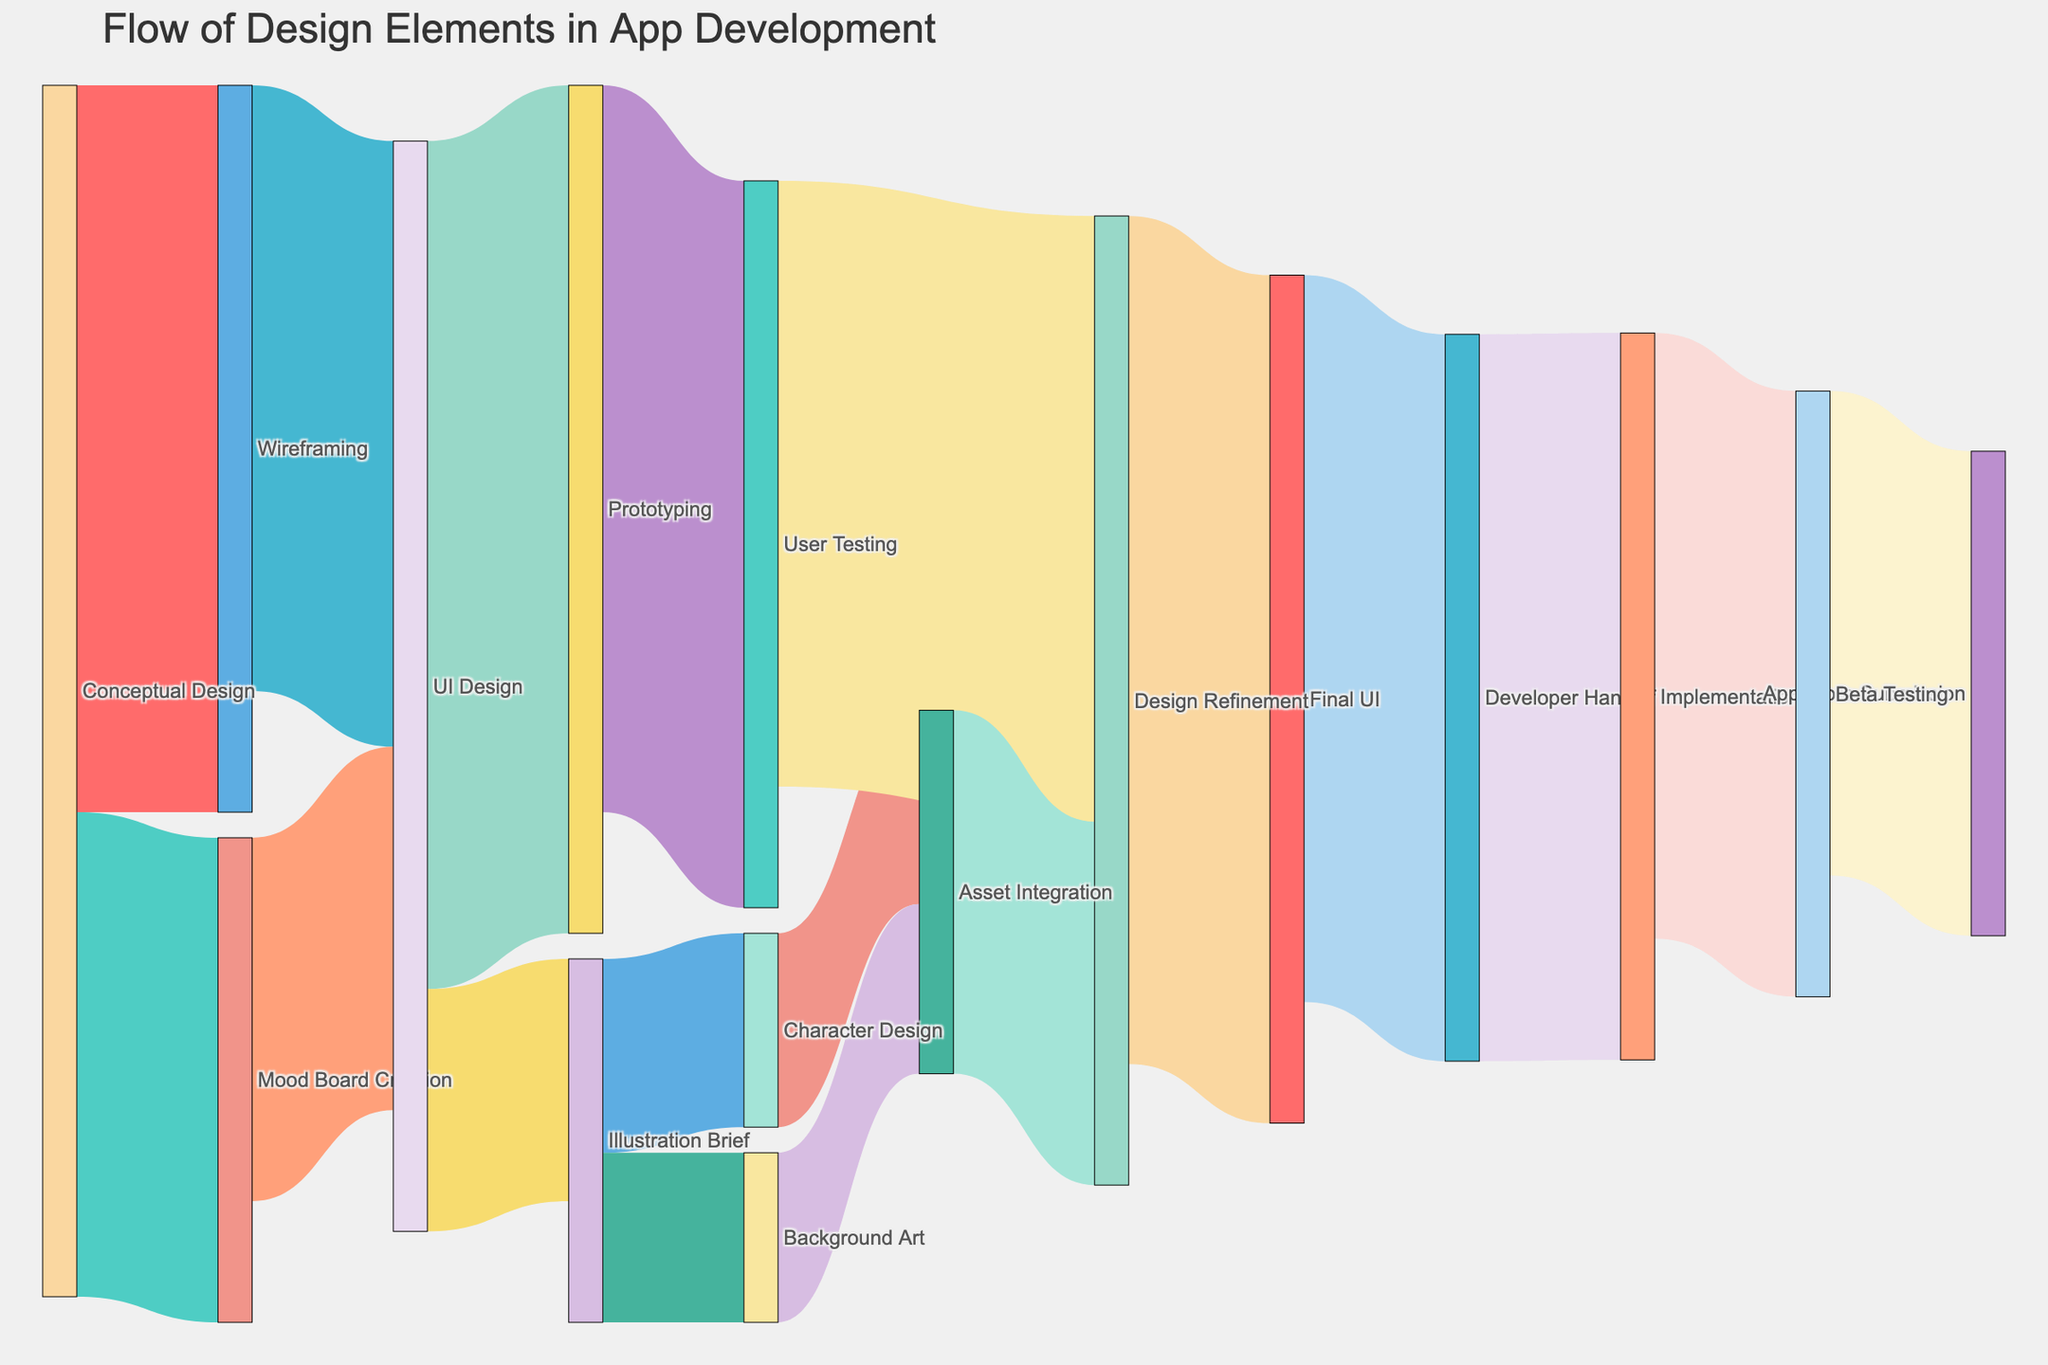What is the title of the Sankey Diagram? The title of a diagram is usually located at the top of the illustration and provides an overview of the content. Here, the title "Flow of Design Elements in App Development" is clearly mentioned at the top of the diagram.
Answer: Flow of Design Elements in App Development What is the total value of flows originating from 'Conceptual Design'? To determine the total value of flows originating from 'Conceptual Design', add the values of all direct outputs: Wireframing (30) and Mood Board Creation (20). Therefore, the total value is 30+20=50.
Answer: 50 Which stage has the highest incoming flow from 'UI Design'? The diagram shows two flows originating from 'UI Design': one going to 'Prototyping' with a value of 35, and the other to 'Illustration Brief' with a value of 10. The highest incoming flow is to 'Prototyping'.
Answer: Prototyping How many design elements flow from 'Illustration Brief' to 'Asset Integration'? To determine the number of design elements flowing to 'Asset Integration', we look at the connections from 'Illustration Brief'. 'Character Design' and 'Background Art' flow to 'Asset Integration' with values of 8 and 7 respectively. Adding these gives 8+7=15.
Answer: 15 Is there any stage where the outgoing value equals the incoming value and what is it? We need to find a stage where the sum of incoming values equals the sum of outgoing values. For example, 'Design Refinement' has incoming values of 25 (from 'User Testing') and 15 (from 'Asset Integration'), totaling 40. Its outgoing value to 'Final UI' is also 40. Thus, outgoing equals incoming for 'Design Refinement'.
Answer: Design Refinement What is the sum of values that eventually lead to 'Implementation'? First, identify the direct flow into 'Implementation': Developer Handoff (30). Now, check what contributes to 'Developer Handoff': Final UI (30). 'Final UI' gets 35 from 'Design Refinement', which in turn gets values from 'User Testing' (25) and 'Asset Integration' (15). Sum the values: 30 (Developer Handoff) + 30 (Final UI) + 35 (Design Refinement) + 25 (User Testing) + 15 (Asset Integration). But since some stages recursively contribute, focus only on direct sums: 30 (Developer Handoff) + 30 (Final UI).
Answer: 60 